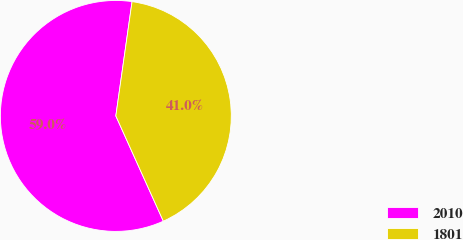Convert chart. <chart><loc_0><loc_0><loc_500><loc_500><pie_chart><fcel>2010<fcel>1801<nl><fcel>58.99%<fcel>41.01%<nl></chart> 